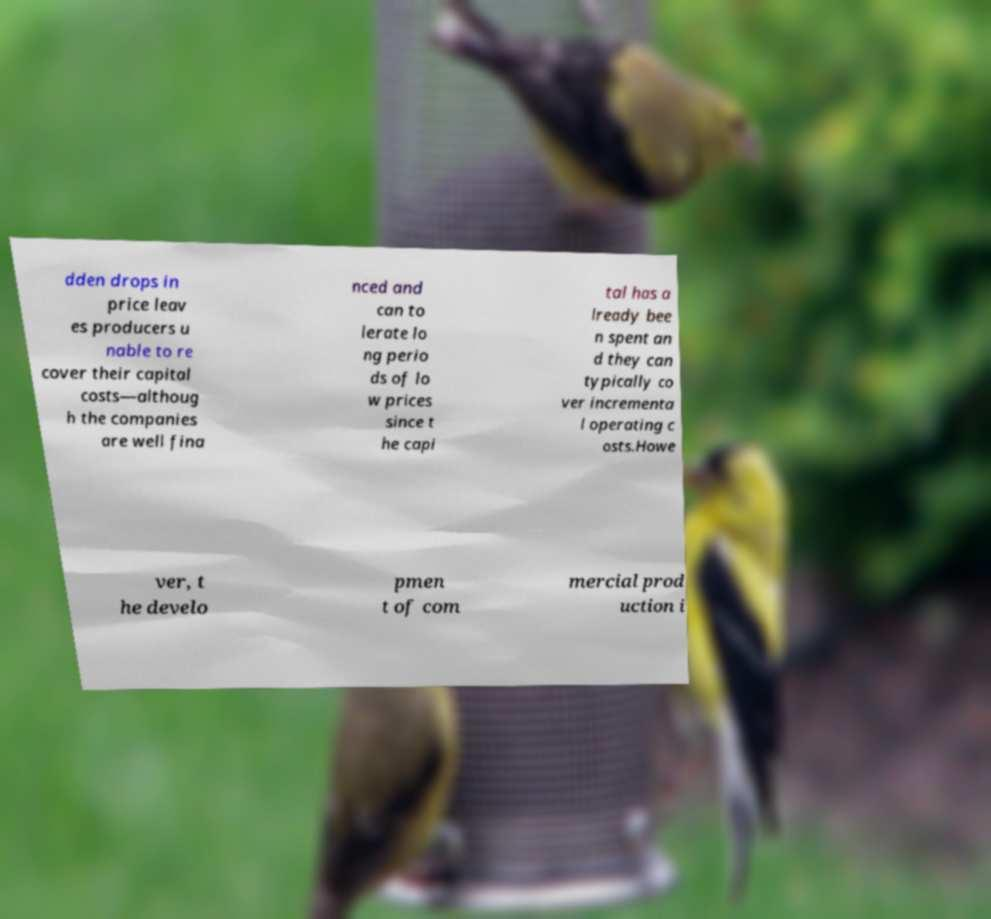Please read and relay the text visible in this image. What does it say? dden drops in price leav es producers u nable to re cover their capital costs—althoug h the companies are well fina nced and can to lerate lo ng perio ds of lo w prices since t he capi tal has a lready bee n spent an d they can typically co ver incrementa l operating c osts.Howe ver, t he develo pmen t of com mercial prod uction i 